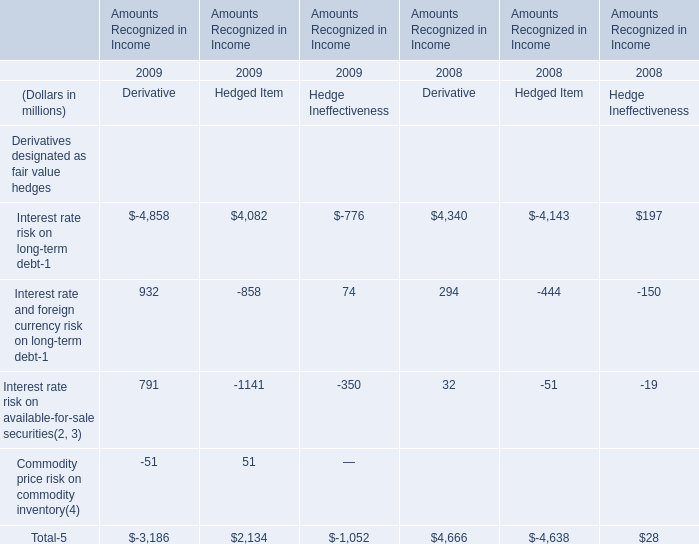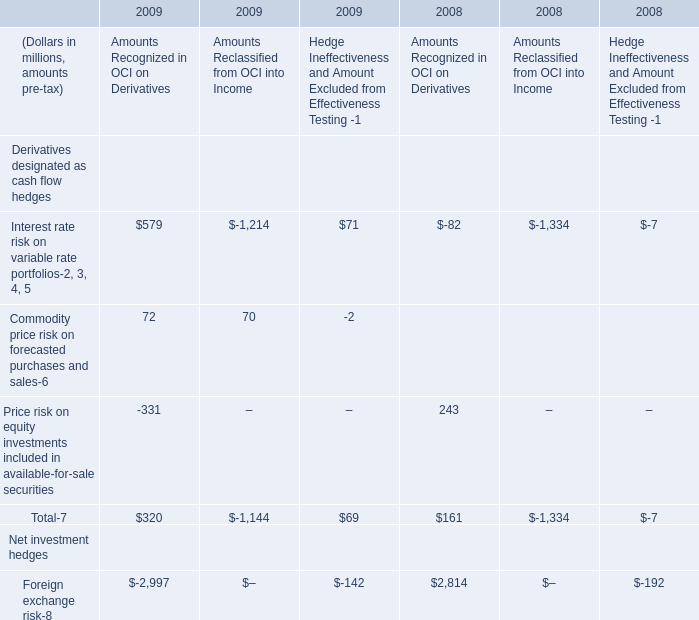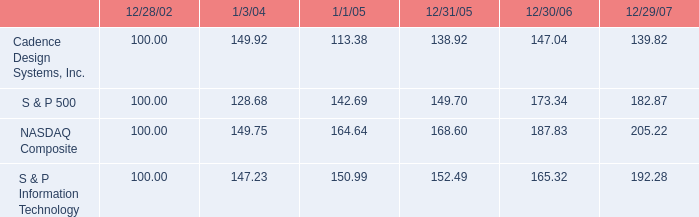what is the roi of an investment in cadence design system from 2006 to 2007? 
Computations: ((139.82 - 147.04) / 147.04)
Answer: -0.0491. 